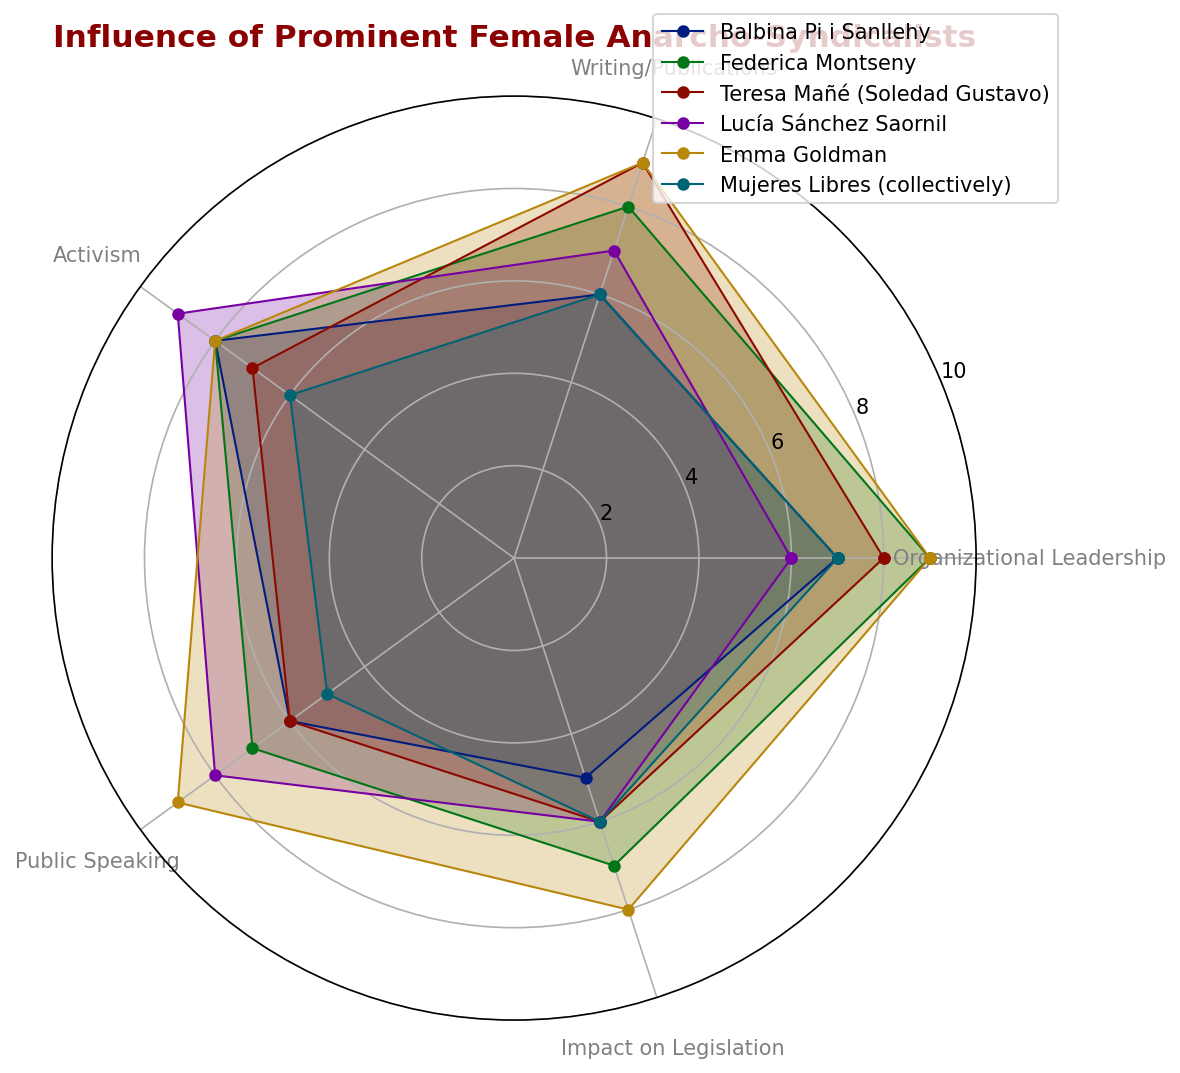Which individual has the highest value in Organizational Leadership? From the radar chart, look at the Organizational Leadership axis and identify which line extends the furthest. Federica Montseny and Emma Goldman both reach the top range for Organizational Leadership.
Answer: Federica Montseny and Emma Goldman Who has the lowest impact on Legislation? Compare the lengths of the lines on the "Impact on Legislation" axis. Balbina Pi i Sanllehy has the lowest value, extending to 5.
Answer: Balbina Pi i Sanllehy Which two individuals have equal values in Writing/Publications? Find the Writing/Publications axis and identify the individuals whose lines reach the same point (6). Balbina Pi i Sanllehy and Mujeres Libres both have a value of 6.
Answer: Balbina Pi i Sanllehy and Mujeres Libres Between Emma Goldman and Lucía Sánchez Saornil, who has a higher value in Activism? Check the Activism axis and compare the lengths of the lines for Emma Goldman and Lucía Sánchez Saornil. Emma Goldman's line extends further to 8, compared to Lucía Sánchez Saornil's 9.
Answer: Lucía Sánchez Saornil What is the average value of Balbina Pi i Sanllehy across all categories? Add the values for Balbina Pi i Sanllehy (7 + 6 + 8 + 6 + 5 = 32) and divide by 5 (the number of categories): 32/5 = 6.4.
Answer: 6.4 Who has both high Activism and high Public Speaking values? Observe the Activism and Public Speaking axes and identify individuals with high values (≥8). Lucía Sánchez Saornil has high values (9 in Activism and 8 in Public Speaking).
Answer: Lucía Sánchez Saornil Which category does Balbina Pi i Sanllehy score the highest in? Look at each axis for Balbina Pi i Sanllehy and identify the highest value. She scores 8 in Activism, which is her highest rating.
Answer: Activism Compare Teresa Mañé and Emma Goldman in Writing/Publications. Who scores higher? Locate the Writing/Publications axis and compare their values. Teresa Mañé has a value of 9, while Emma Goldman also has a value of 9.
Answer: Equal Which individual or group has the lowest rating in Public Speaking? On the Public Speaking axis, identify the shortest lines. Mujeres Libres has the lowest rating, extending to 5.
Answer: Mujeres Libres 